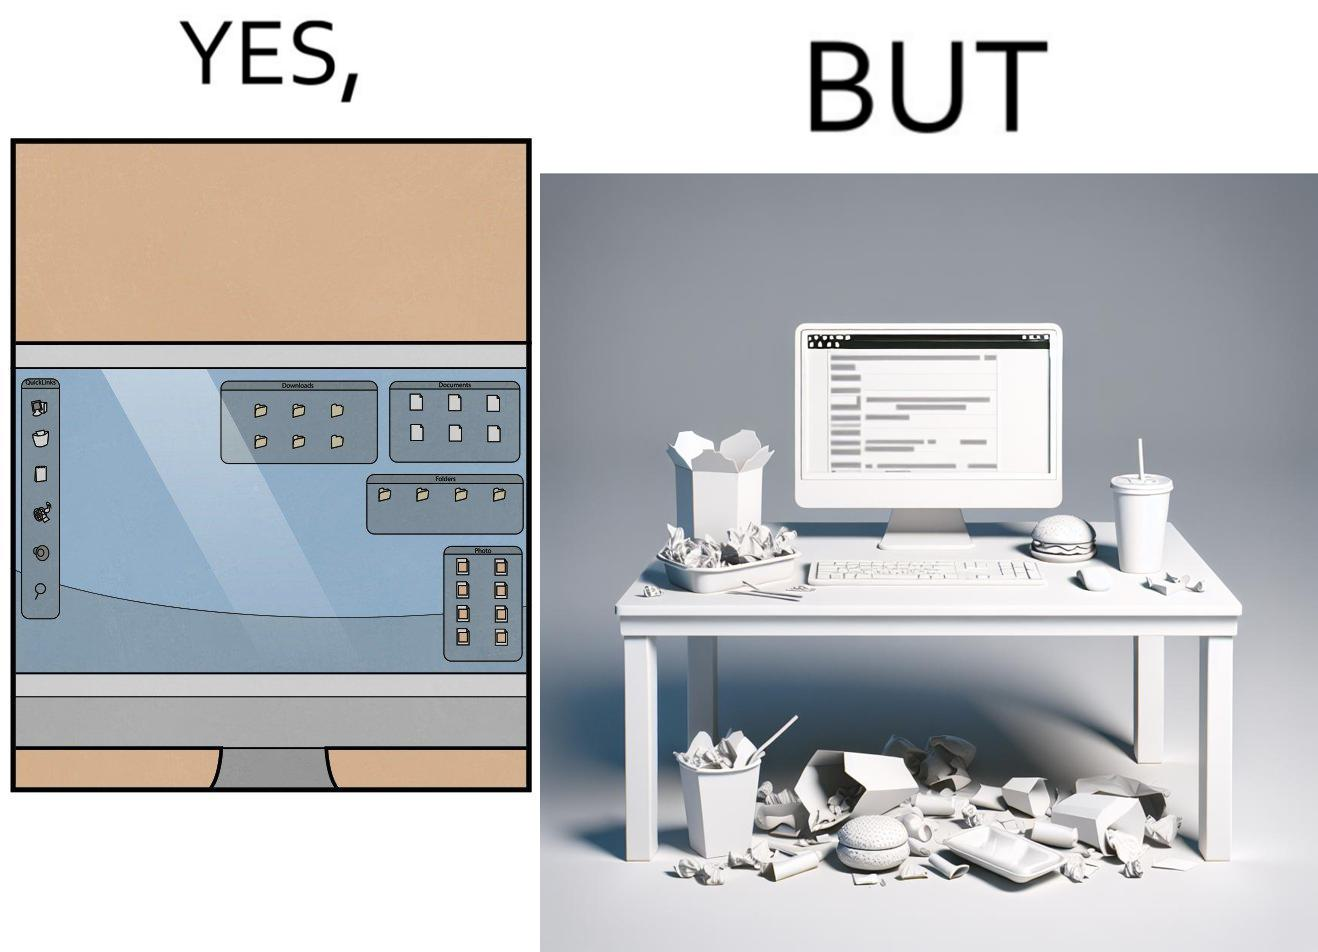What do you see in each half of this image? In the left part of the image: A desktop screen opened in a computer monitor. In the right part of the image: A desktop screen opened in a computer monitor on a table littered with used food packets, dirty plates, and wrappers 